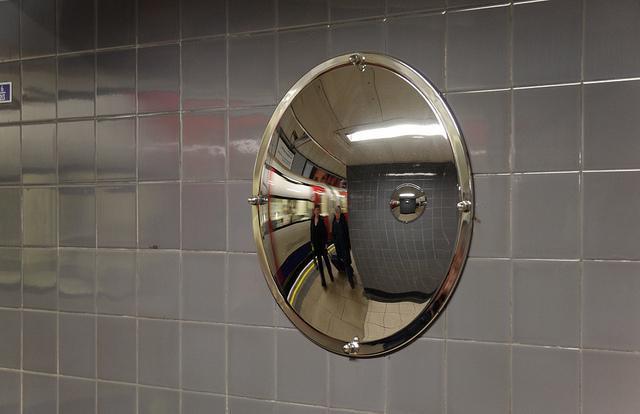How many cows in the picture?
Give a very brief answer. 0. 